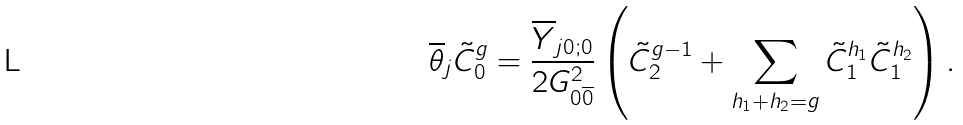<formula> <loc_0><loc_0><loc_500><loc_500>\overline { \theta } _ { j } \tilde { C } _ { 0 } ^ { g } = \frac { \overline { Y } _ { j 0 ; 0 } } { 2 G _ { 0 \overline { 0 } } ^ { 2 } } \left ( \tilde { C } _ { 2 } ^ { g - 1 } + \sum _ { h _ { 1 } + h _ { 2 } = g } \tilde { C } _ { 1 } ^ { h _ { 1 } } \tilde { C } _ { 1 } ^ { h _ { 2 } } \right ) .</formula> 